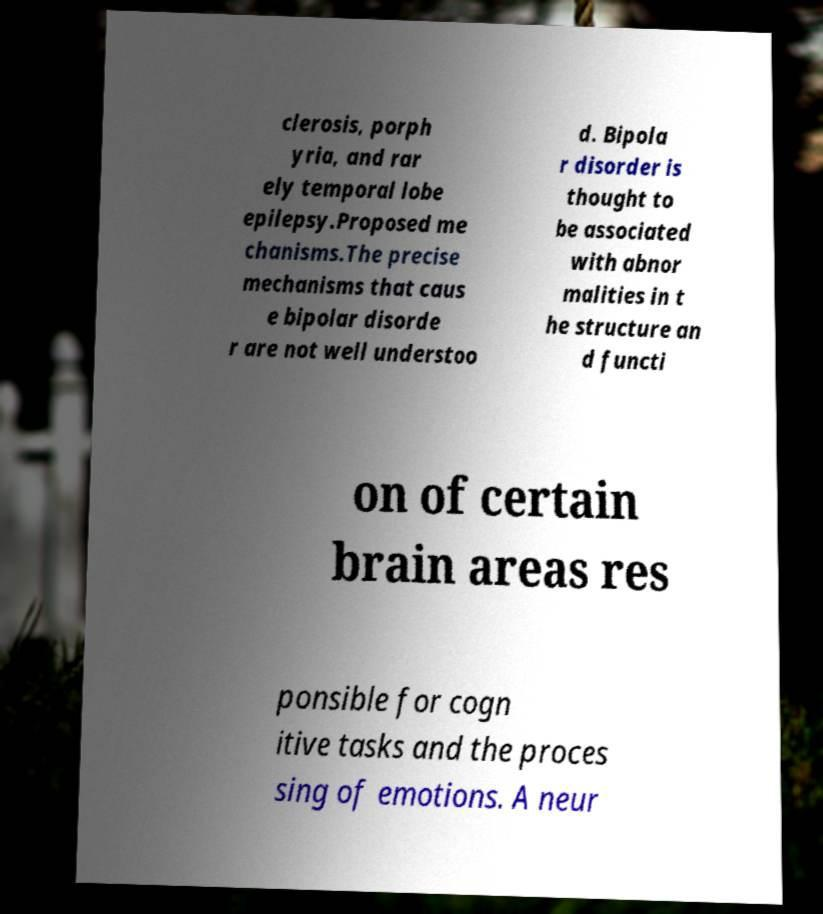Could you extract and type out the text from this image? clerosis, porph yria, and rar ely temporal lobe epilepsy.Proposed me chanisms.The precise mechanisms that caus e bipolar disorde r are not well understoo d. Bipola r disorder is thought to be associated with abnor malities in t he structure an d functi on of certain brain areas res ponsible for cogn itive tasks and the proces sing of emotions. A neur 